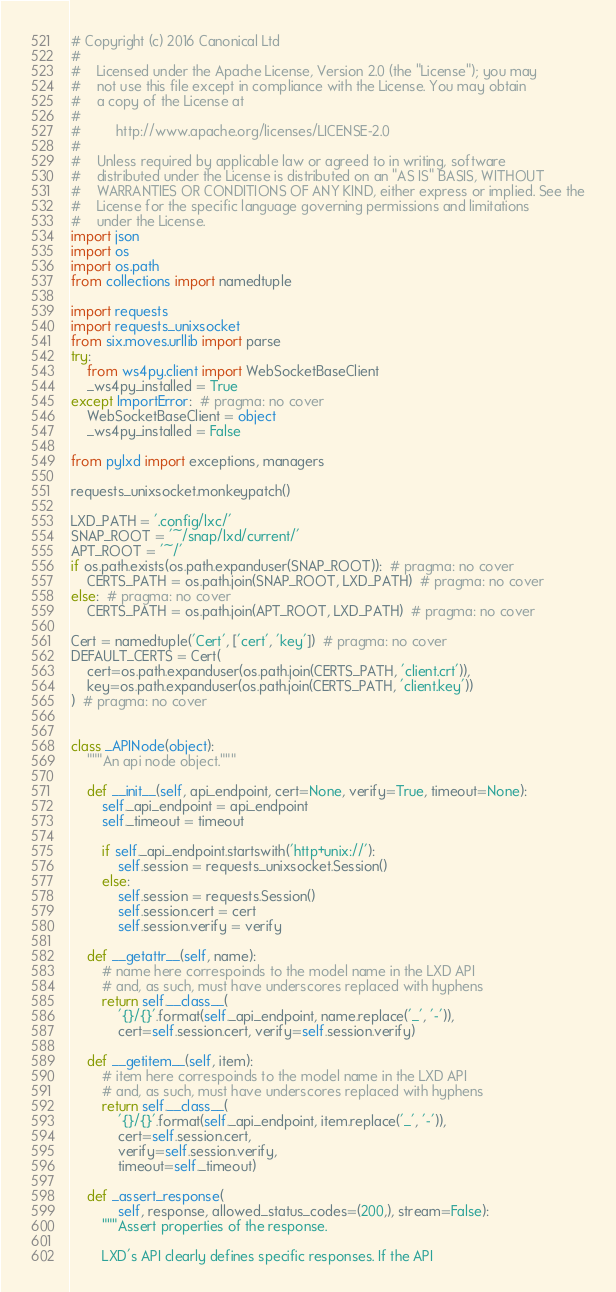Convert code to text. <code><loc_0><loc_0><loc_500><loc_500><_Python_># Copyright (c) 2016 Canonical Ltd
#
#    Licensed under the Apache License, Version 2.0 (the "License"); you may
#    not use this file except in compliance with the License. You may obtain
#    a copy of the License at
#
#         http://www.apache.org/licenses/LICENSE-2.0
#
#    Unless required by applicable law or agreed to in writing, software
#    distributed under the License is distributed on an "AS IS" BASIS, WITHOUT
#    WARRANTIES OR CONDITIONS OF ANY KIND, either express or implied. See the
#    License for the specific language governing permissions and limitations
#    under the License.
import json
import os
import os.path
from collections import namedtuple

import requests
import requests_unixsocket
from six.moves.urllib import parse
try:
    from ws4py.client import WebSocketBaseClient
    _ws4py_installed = True
except ImportError:  # pragma: no cover
    WebSocketBaseClient = object
    _ws4py_installed = False

from pylxd import exceptions, managers

requests_unixsocket.monkeypatch()

LXD_PATH = '.config/lxc/'
SNAP_ROOT = '~/snap/lxd/current/'
APT_ROOT = '~/'
if os.path.exists(os.path.expanduser(SNAP_ROOT)):  # pragma: no cover
    CERTS_PATH = os.path.join(SNAP_ROOT, LXD_PATH)  # pragma: no cover
else:  # pragma: no cover
    CERTS_PATH = os.path.join(APT_ROOT, LXD_PATH)  # pragma: no cover

Cert = namedtuple('Cert', ['cert', 'key'])  # pragma: no cover
DEFAULT_CERTS = Cert(
    cert=os.path.expanduser(os.path.join(CERTS_PATH, 'client.crt')),
    key=os.path.expanduser(os.path.join(CERTS_PATH, 'client.key'))
)  # pragma: no cover


class _APINode(object):
    """An api node object."""

    def __init__(self, api_endpoint, cert=None, verify=True, timeout=None):
        self._api_endpoint = api_endpoint
        self._timeout = timeout

        if self._api_endpoint.startswith('http+unix://'):
            self.session = requests_unixsocket.Session()
        else:
            self.session = requests.Session()
            self.session.cert = cert
            self.session.verify = verify

    def __getattr__(self, name):
        # name here correspoinds to the model name in the LXD API
        # and, as such, must have underscores replaced with hyphens
        return self.__class__(
            '{}/{}'.format(self._api_endpoint, name.replace('_', '-')),
            cert=self.session.cert, verify=self.session.verify)

    def __getitem__(self, item):
        # item here correspoinds to the model name in the LXD API
        # and, as such, must have underscores replaced with hyphens
        return self.__class__(
            '{}/{}'.format(self._api_endpoint, item.replace('_', '-')),
            cert=self.session.cert,
            verify=self.session.verify,
            timeout=self._timeout)

    def _assert_response(
            self, response, allowed_status_codes=(200,), stream=False):
        """Assert properties of the response.

        LXD's API clearly defines specific responses. If the API</code> 